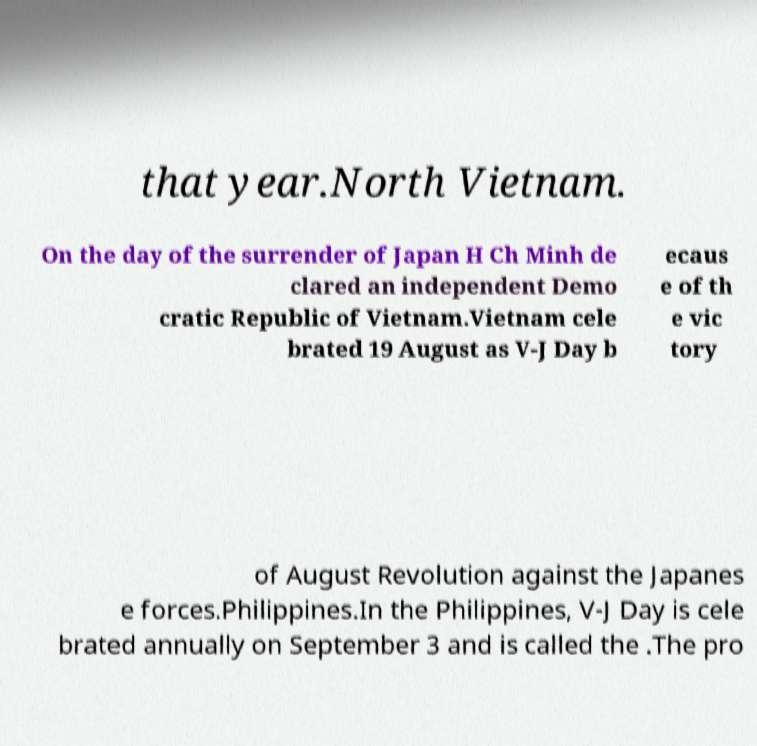Please read and relay the text visible in this image. What does it say? that year.North Vietnam. On the day of the surrender of Japan H Ch Minh de clared an independent Demo cratic Republic of Vietnam.Vietnam cele brated 19 August as V-J Day b ecaus e of th e vic tory of August Revolution against the Japanes e forces.Philippines.In the Philippines, V-J Day is cele brated annually on September 3 and is called the .The pro 